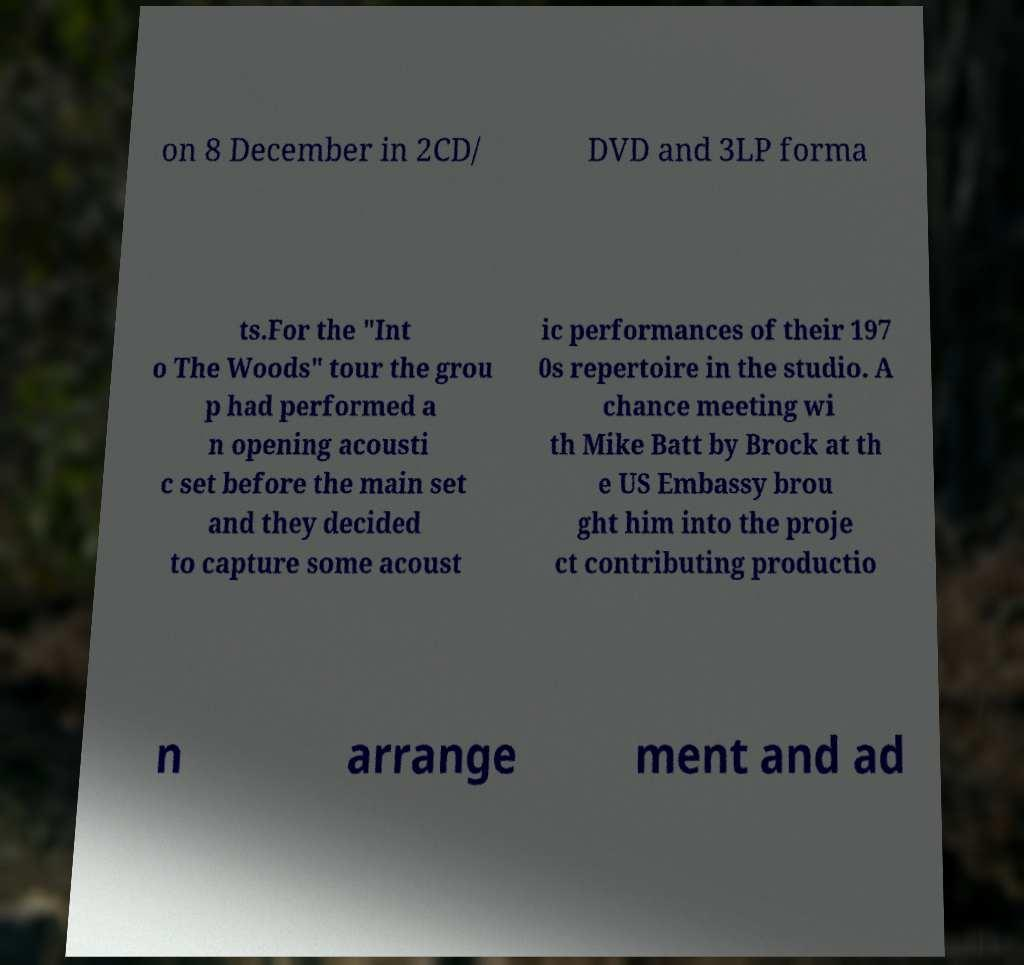Please read and relay the text visible in this image. What does it say? on 8 December in 2CD/ DVD and 3LP forma ts.For the "Int o The Woods" tour the grou p had performed a n opening acousti c set before the main set and they decided to capture some acoust ic performances of their 197 0s repertoire in the studio. A chance meeting wi th Mike Batt by Brock at th e US Embassy brou ght him into the proje ct contributing productio n arrange ment and ad 